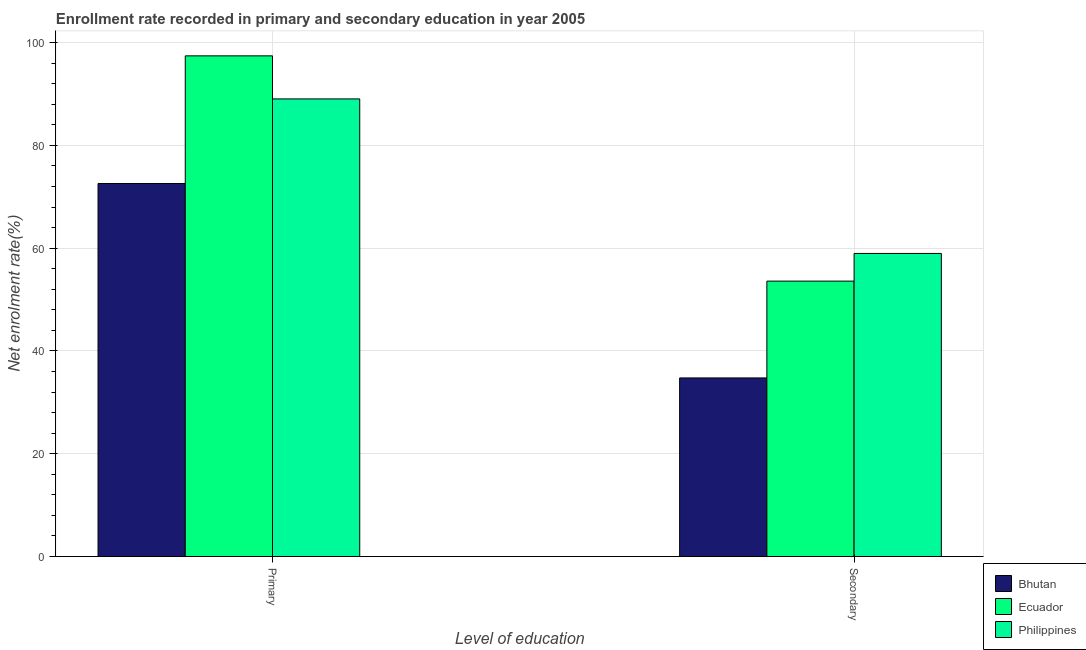How many different coloured bars are there?
Provide a short and direct response. 3. Are the number of bars on each tick of the X-axis equal?
Provide a succinct answer. Yes. How many bars are there on the 1st tick from the left?
Ensure brevity in your answer.  3. What is the label of the 2nd group of bars from the left?
Give a very brief answer. Secondary. What is the enrollment rate in primary education in Ecuador?
Make the answer very short. 97.41. Across all countries, what is the maximum enrollment rate in primary education?
Provide a short and direct response. 97.41. Across all countries, what is the minimum enrollment rate in secondary education?
Provide a succinct answer. 34.75. In which country was the enrollment rate in primary education maximum?
Your answer should be very brief. Ecuador. In which country was the enrollment rate in secondary education minimum?
Provide a short and direct response. Bhutan. What is the total enrollment rate in secondary education in the graph?
Keep it short and to the point. 147.29. What is the difference between the enrollment rate in primary education in Ecuador and that in Bhutan?
Offer a very short reply. 24.83. What is the difference between the enrollment rate in primary education in Bhutan and the enrollment rate in secondary education in Philippines?
Provide a short and direct response. 13.61. What is the average enrollment rate in secondary education per country?
Make the answer very short. 49.1. What is the difference between the enrollment rate in primary education and enrollment rate in secondary education in Bhutan?
Provide a short and direct response. 37.83. In how many countries, is the enrollment rate in primary education greater than 12 %?
Offer a very short reply. 3. What is the ratio of the enrollment rate in secondary education in Philippines to that in Ecuador?
Provide a short and direct response. 1.1. Is the enrollment rate in secondary education in Bhutan less than that in Ecuador?
Give a very brief answer. Yes. In how many countries, is the enrollment rate in secondary education greater than the average enrollment rate in secondary education taken over all countries?
Keep it short and to the point. 2. What does the 2nd bar from the left in Secondary represents?
Your answer should be compact. Ecuador. What does the 2nd bar from the right in Primary represents?
Your response must be concise. Ecuador. Are all the bars in the graph horizontal?
Your answer should be very brief. No. How many countries are there in the graph?
Offer a very short reply. 3. What is the difference between two consecutive major ticks on the Y-axis?
Ensure brevity in your answer.  20. Are the values on the major ticks of Y-axis written in scientific E-notation?
Your answer should be very brief. No. Does the graph contain grids?
Offer a very short reply. Yes. Where does the legend appear in the graph?
Offer a terse response. Bottom right. How many legend labels are there?
Offer a terse response. 3. What is the title of the graph?
Provide a succinct answer. Enrollment rate recorded in primary and secondary education in year 2005. Does "Bahrain" appear as one of the legend labels in the graph?
Your response must be concise. No. What is the label or title of the X-axis?
Offer a very short reply. Level of education. What is the label or title of the Y-axis?
Offer a terse response. Net enrolment rate(%). What is the Net enrolment rate(%) of Bhutan in Primary?
Your answer should be very brief. 72.57. What is the Net enrolment rate(%) in Ecuador in Primary?
Ensure brevity in your answer.  97.41. What is the Net enrolment rate(%) of Philippines in Primary?
Your response must be concise. 89.03. What is the Net enrolment rate(%) in Bhutan in Secondary?
Offer a terse response. 34.75. What is the Net enrolment rate(%) of Ecuador in Secondary?
Make the answer very short. 53.58. What is the Net enrolment rate(%) of Philippines in Secondary?
Offer a terse response. 58.96. Across all Level of education, what is the maximum Net enrolment rate(%) in Bhutan?
Offer a very short reply. 72.57. Across all Level of education, what is the maximum Net enrolment rate(%) in Ecuador?
Offer a very short reply. 97.41. Across all Level of education, what is the maximum Net enrolment rate(%) in Philippines?
Give a very brief answer. 89.03. Across all Level of education, what is the minimum Net enrolment rate(%) in Bhutan?
Ensure brevity in your answer.  34.75. Across all Level of education, what is the minimum Net enrolment rate(%) in Ecuador?
Offer a terse response. 53.58. Across all Level of education, what is the minimum Net enrolment rate(%) of Philippines?
Offer a terse response. 58.96. What is the total Net enrolment rate(%) of Bhutan in the graph?
Ensure brevity in your answer.  107.32. What is the total Net enrolment rate(%) in Ecuador in the graph?
Provide a succinct answer. 150.99. What is the total Net enrolment rate(%) of Philippines in the graph?
Provide a succinct answer. 147.99. What is the difference between the Net enrolment rate(%) in Bhutan in Primary and that in Secondary?
Ensure brevity in your answer.  37.83. What is the difference between the Net enrolment rate(%) in Ecuador in Primary and that in Secondary?
Offer a very short reply. 43.82. What is the difference between the Net enrolment rate(%) of Philippines in Primary and that in Secondary?
Your answer should be compact. 30.06. What is the difference between the Net enrolment rate(%) in Bhutan in Primary and the Net enrolment rate(%) in Ecuador in Secondary?
Offer a terse response. 18.99. What is the difference between the Net enrolment rate(%) in Bhutan in Primary and the Net enrolment rate(%) in Philippines in Secondary?
Your answer should be very brief. 13.61. What is the difference between the Net enrolment rate(%) in Ecuador in Primary and the Net enrolment rate(%) in Philippines in Secondary?
Provide a short and direct response. 38.44. What is the average Net enrolment rate(%) of Bhutan per Level of education?
Your response must be concise. 53.66. What is the average Net enrolment rate(%) in Ecuador per Level of education?
Your answer should be very brief. 75.49. What is the average Net enrolment rate(%) of Philippines per Level of education?
Provide a succinct answer. 74. What is the difference between the Net enrolment rate(%) in Bhutan and Net enrolment rate(%) in Ecuador in Primary?
Provide a short and direct response. -24.83. What is the difference between the Net enrolment rate(%) of Bhutan and Net enrolment rate(%) of Philippines in Primary?
Keep it short and to the point. -16.45. What is the difference between the Net enrolment rate(%) of Ecuador and Net enrolment rate(%) of Philippines in Primary?
Ensure brevity in your answer.  8.38. What is the difference between the Net enrolment rate(%) of Bhutan and Net enrolment rate(%) of Ecuador in Secondary?
Offer a very short reply. -18.84. What is the difference between the Net enrolment rate(%) in Bhutan and Net enrolment rate(%) in Philippines in Secondary?
Give a very brief answer. -24.22. What is the difference between the Net enrolment rate(%) of Ecuador and Net enrolment rate(%) of Philippines in Secondary?
Offer a very short reply. -5.38. What is the ratio of the Net enrolment rate(%) of Bhutan in Primary to that in Secondary?
Ensure brevity in your answer.  2.09. What is the ratio of the Net enrolment rate(%) in Ecuador in Primary to that in Secondary?
Keep it short and to the point. 1.82. What is the ratio of the Net enrolment rate(%) of Philippines in Primary to that in Secondary?
Offer a terse response. 1.51. What is the difference between the highest and the second highest Net enrolment rate(%) in Bhutan?
Ensure brevity in your answer.  37.83. What is the difference between the highest and the second highest Net enrolment rate(%) of Ecuador?
Offer a very short reply. 43.82. What is the difference between the highest and the second highest Net enrolment rate(%) of Philippines?
Give a very brief answer. 30.06. What is the difference between the highest and the lowest Net enrolment rate(%) of Bhutan?
Offer a terse response. 37.83. What is the difference between the highest and the lowest Net enrolment rate(%) in Ecuador?
Offer a very short reply. 43.82. What is the difference between the highest and the lowest Net enrolment rate(%) of Philippines?
Your response must be concise. 30.06. 